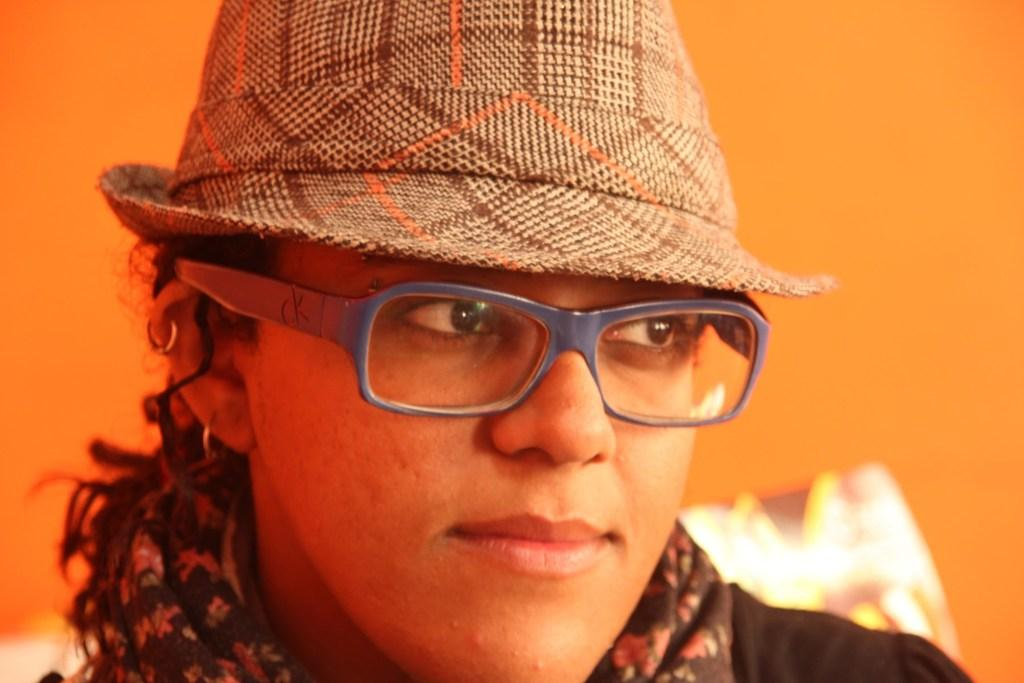Who or what is the main subject in the image? There is a person in the image. What accessories is the person wearing? The person is wearing spectacles and a hat. What is the color of the background in the image? The background color is orange. What type of plant can be seen in the background of the image? There is no plant visible in the background of the image; the background color is orange. 